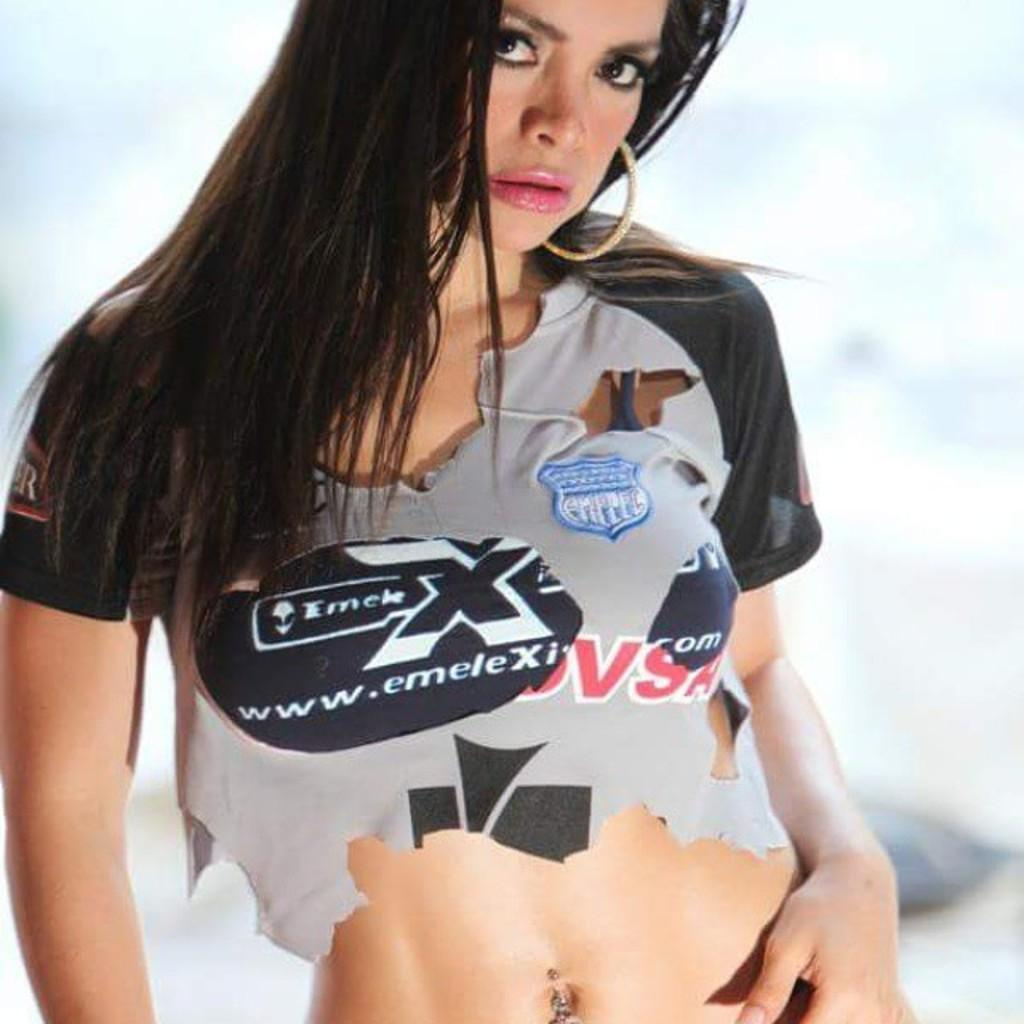<image>
Give a short and clear explanation of the subsequent image. A woman with an exposed belly wears a cropped Emele X shirt. 